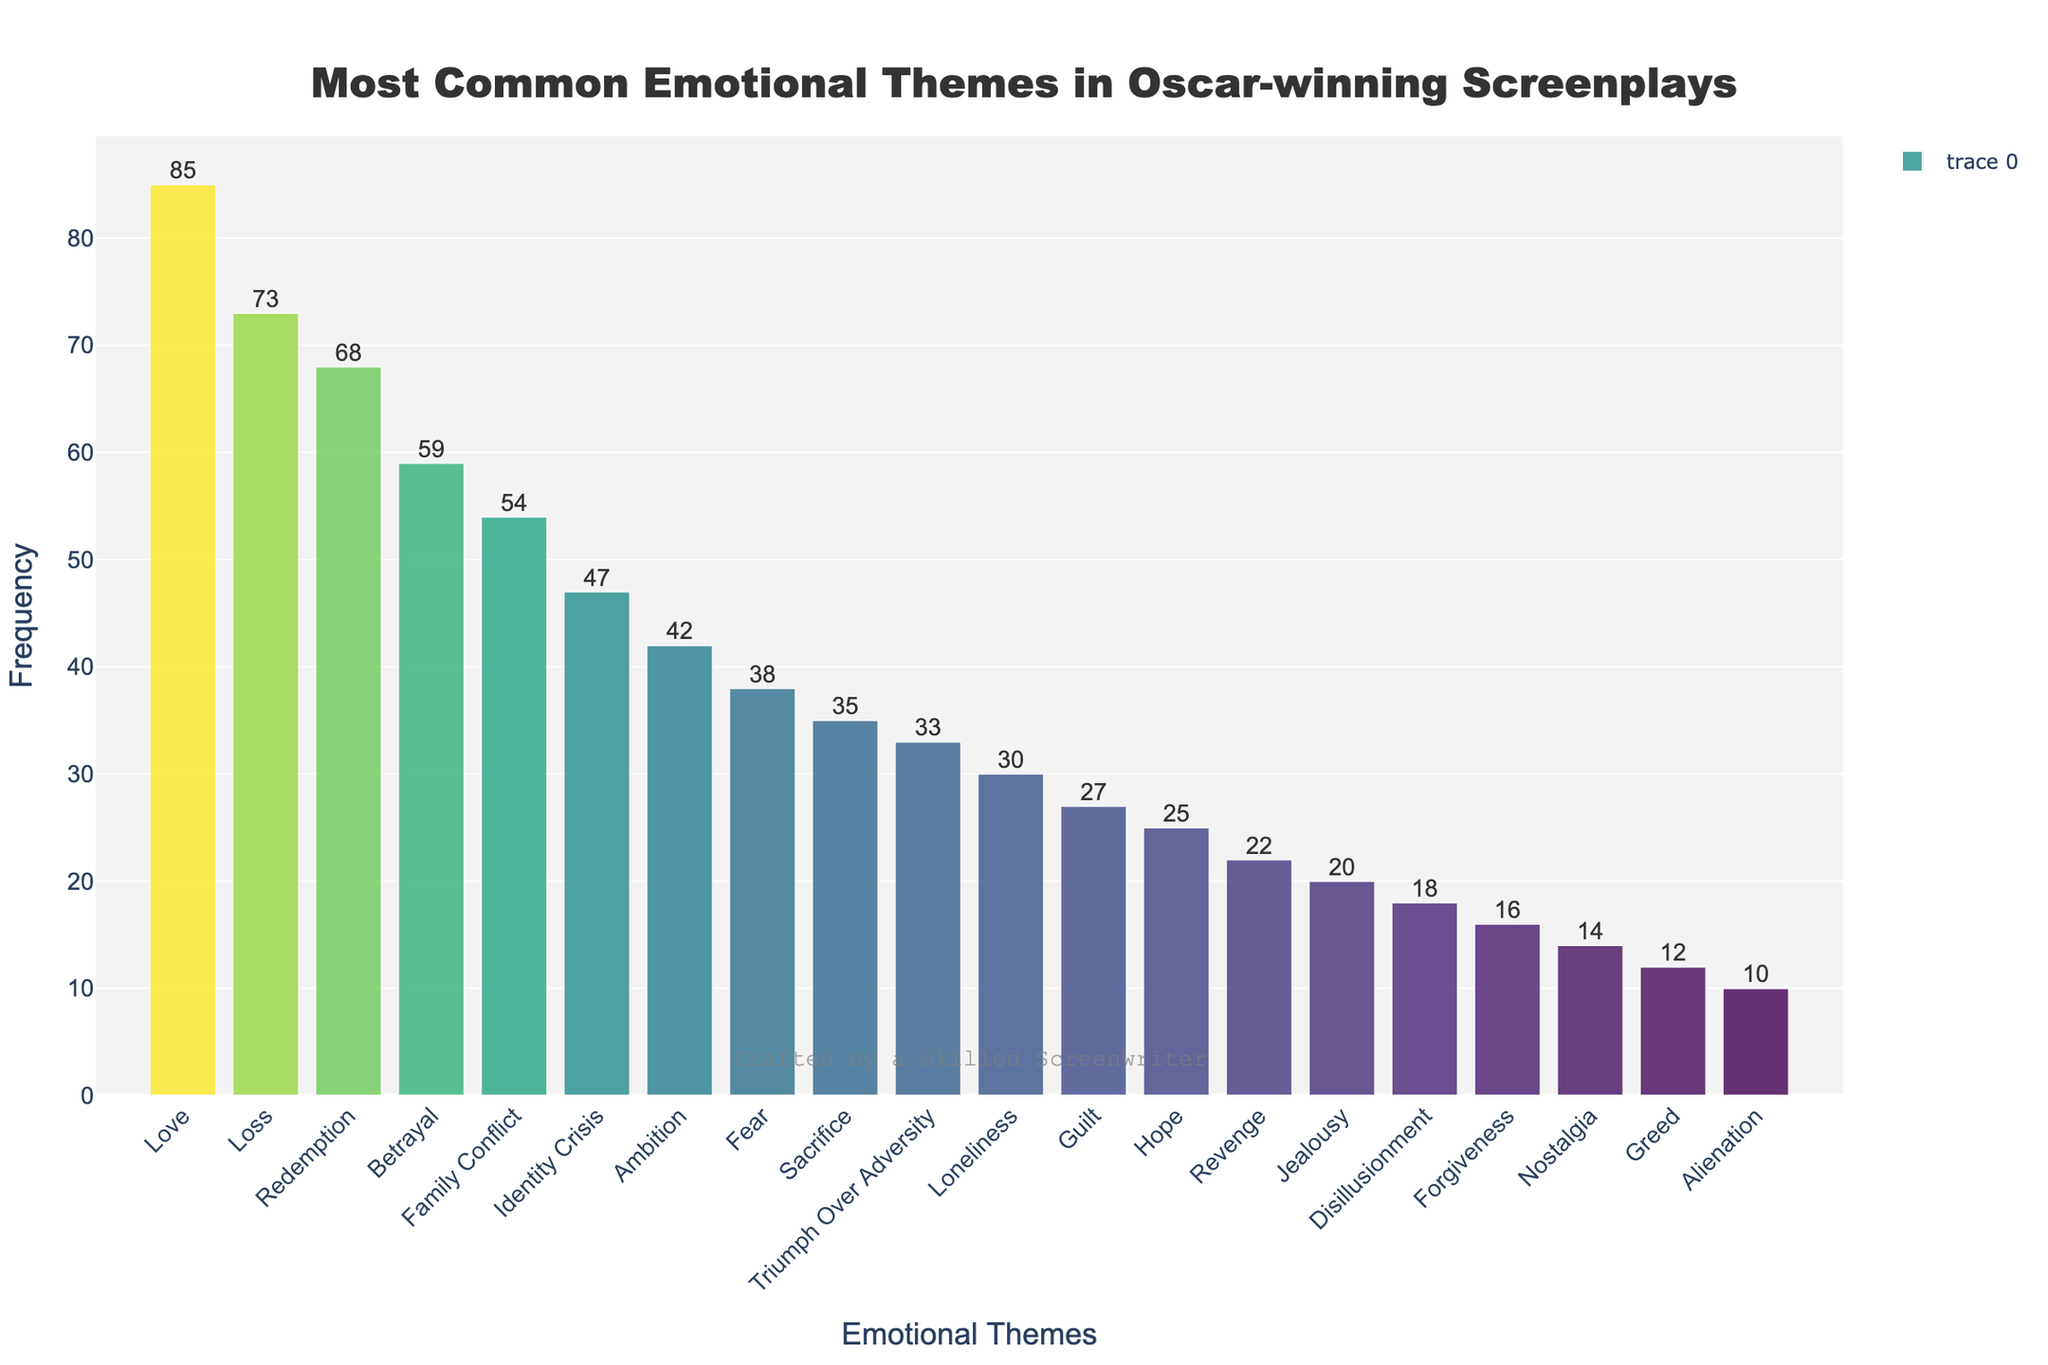What's the most common emotional theme in Oscar-winning screenplays? The height of the highest bar indicates the most common theme. By looking at the figure, "Love" has the highest bar, which means it's the most common emotional theme.
Answer: Love Which emotional theme occurs least frequently? The height of the shortest bar indicates the least frequent theme. By looking at the figure, "Alienation" has the shortest bar, making it the least frequent emotional theme.
Answer: Alienation How many emotional themes have a frequency of 50 or higher? By observing the bar heights and their corresponding frequency labels, count the bars that have a frequency of 50 or higher. The themes "Love," "Loss," "Redemption," "Betrayal," and "Family Conflict" fall into this category.
Answer: 5 Which themes have a frequency exactly between 30 and 40? Identify bars whose height indicates a frequency within the 30 to 40 range. The themes "Fear," "Sacrifice," and "Triumph Over Adversity" fall into this range.
Answer: Fear, Sacrifice, Triumph Over Adversity What's the combined frequency of "Love" and "Greed"? Add the frequencies of "Love" and "Greed" by referring to their respective bar heights. "Love" has a frequency of 85 and "Greed" has a frequency of 12, leading to a combined frequency of 85 + 12 = 97.
Answer: 97 Which emotional theme is more frequent: "Hope" or "Revenge"? Compare the heights of the bars for "Hope" and "Revenge". "Hope" has a higher bar, indicating it is more frequent than "Revenge".
Answer: Hope Is "Sacrifice" more frequent than "Guilt"? By comparing the heights of their bars, see that "Sacrifice" has a greater height (frequency) than "Guilt". "Sacrifice" has a frequency of 35 and "Guilt" has a frequency of 27.
Answer: Yes What is the difference in frequency between "Ambition" and "Fear"? Subtract the frequency of "Fear" from the frequency of "Ambition". "Ambition" has a frequency of 42 and "Fear" has a frequency of 38. The difference is 42 - 38 = 4.
Answer: 4 Which emotional themes are represented by bars with nearly the same height? Observe the bars and look for those that are very close in height. "Fear" (38) and "Sacrifice" (35), as well as "Hope" (25) and "Guilt" (27) have nearly the same bar heights.
Answer: Fear and Sacrifice; Hope and Guilt 